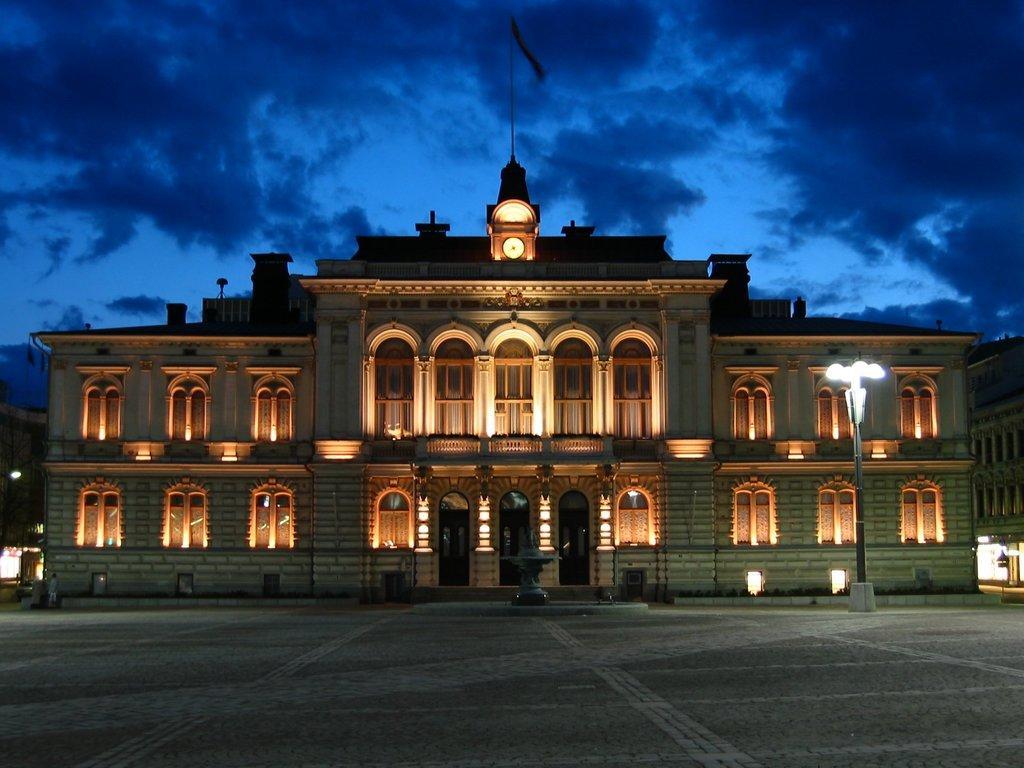Please provide a concise description of this image. this is the big palace and this is a clock and this is the parking area. 